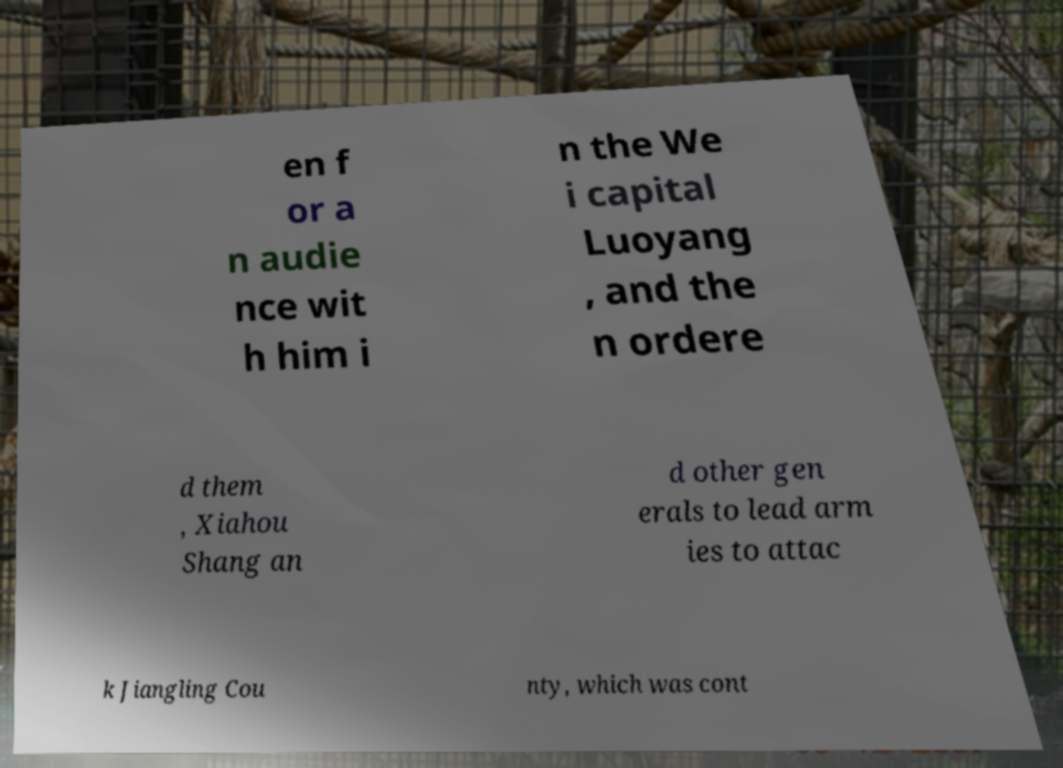Could you extract and type out the text from this image? en f or a n audie nce wit h him i n the We i capital Luoyang , and the n ordere d them , Xiahou Shang an d other gen erals to lead arm ies to attac k Jiangling Cou nty, which was cont 